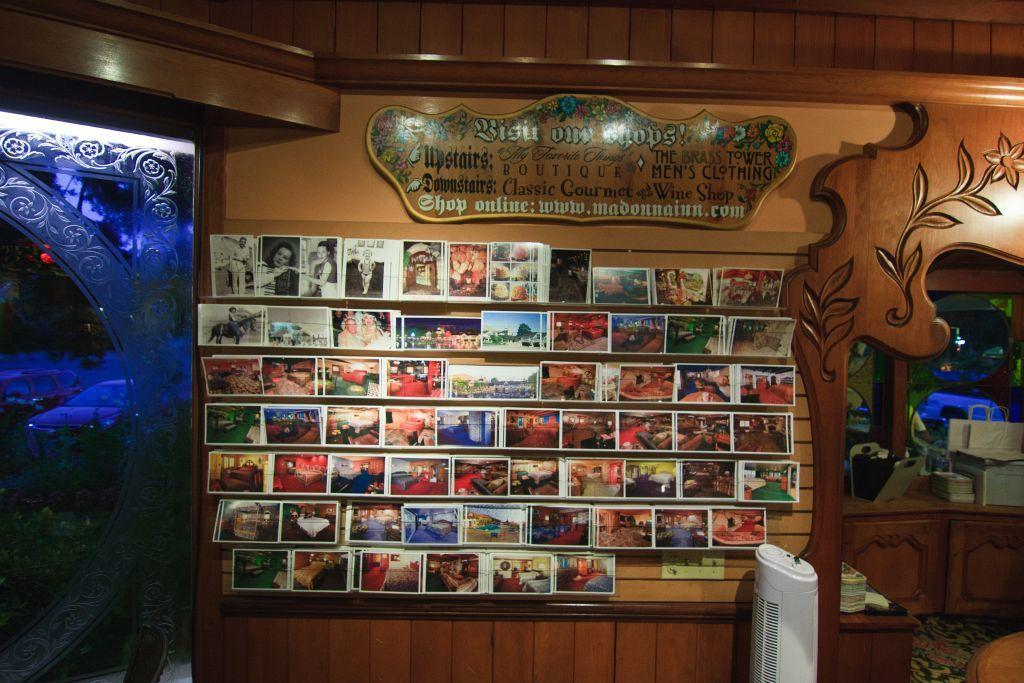What is the main object in the image with text on it? There is a wooden board with text in the image. What else can be seen in the image besides the wooden board? There are photos, a cupboard with boxes, a paper bag on the cupboard, and a tower fan in the image. Can you describe the wood carving in the image? There is a wood carving in the image, but no specific details about its appearance are provided. What is the purpose of the tower fan in the image? The purpose of the tower fan in the image is to provide air circulation, but this is not explicitly stated in the facts. What type of mitten is being used to hold the jar in the image? There is no mitten or jar present in the image. What month is depicted in the image? The facts provided do not mention any specific month or time of year. 